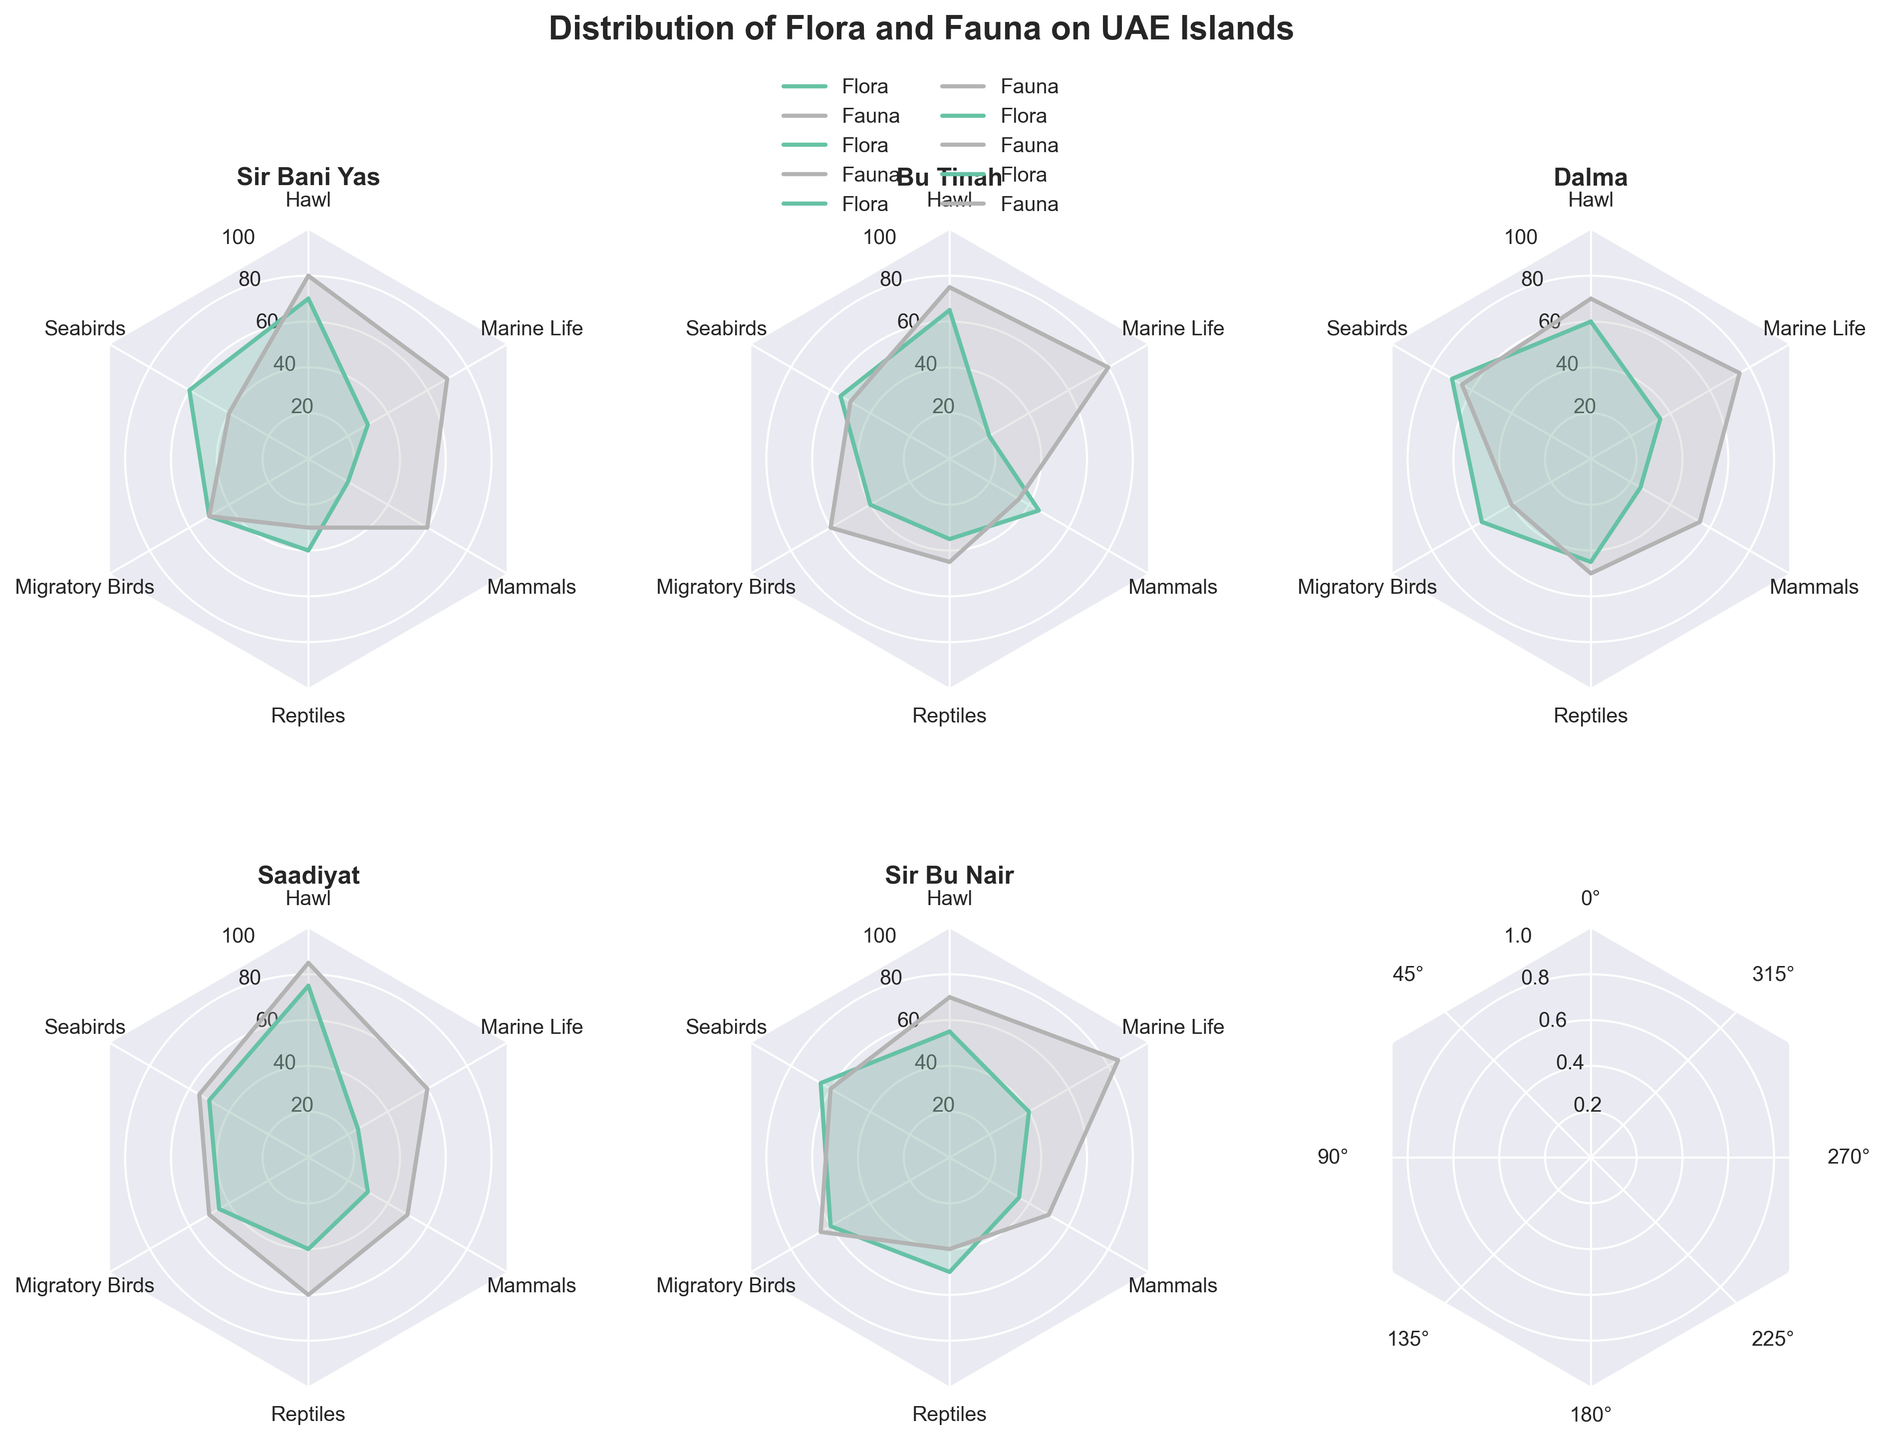Which island has the highest distribution of Hawl for Flora? By looking at the radar charts, Sir Bani Yas has the highest value for Hawl in the Flora category, which reaches up to 70.
Answer: Sir Bani Yas What's the average distribution of Seabirds for Fauna across all islands? Calculate the sum of the Seabirds values across all Fauna categories for each island and then divide by the number of islands: (40 + 50 + 65 + 55 + 60) / 5 = 54.
Answer: 54 Which island has the largest difference in the distribution of Reptiles between Flora and Fauna? For each island, subtract the Flora value for Reptiles from the Fauna value: Sir Bani Yas (30 - 40 = -10), Bu Tinah (45 - 35 = 10), Dalma (50 - 45 = 5), Saadiyat (60 - 40 = 20), Sir Bu Nair (40 - 50 = -10). Saadiyat has the largest difference of 20.
Answer: Saadiyat Which category (Flora or Fauna) has a higher distribution of Mammals on Dalma island? Look at the values for Mammals in both categories for Dalma island: Flora (25), Fauna (55). The value for Mammals in Fauna is higher.
Answer: Fauna What is the common factor of highest distribution seen across categories among all the islands? By examining each radar chart, the Fauna category shows higher values across different types in most islands. Specifically, Mammals, Marine Life, and Seabirds have higher values in Fauna compared to Flora across different islands.
Answer: Fauna Which island has the highest overall distribution of Flora and Fauna combined for Marine Life? Add the values for Marine Life in both Flora and Fauna categories for each island and compare them: Sir Bani Yas (30+70=100), Bu Tinah (20+80=100), Dalma (35+75=110), Saadiyat (25+60=85), Sir Bu Nair (40+85=125). Sir Bu Nair has the highest combined Marine Life distribution.
Answer: Sir Bu Nair Which island has the least presence of Migratory Birds in the Flora category? By looking at the values for Migratory Birds in the Flora category, Bu Tinah has the least presence with a value of 40.
Answer: Bu Tinah 